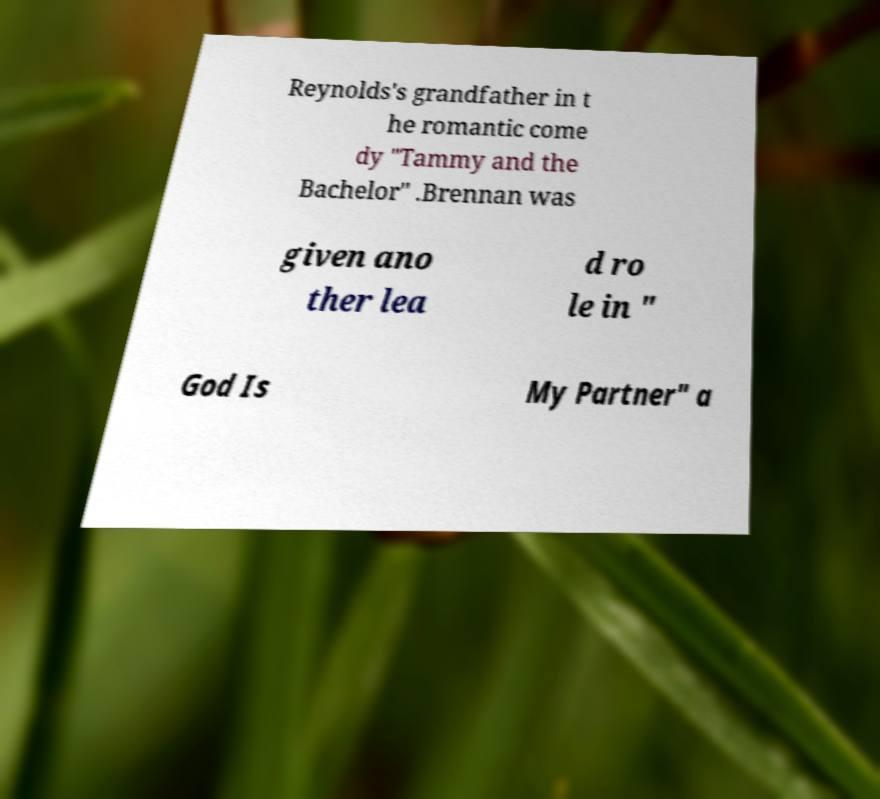For documentation purposes, I need the text within this image transcribed. Could you provide that? Reynolds's grandfather in t he romantic come dy "Tammy and the Bachelor" .Brennan was given ano ther lea d ro le in " God Is My Partner" a 